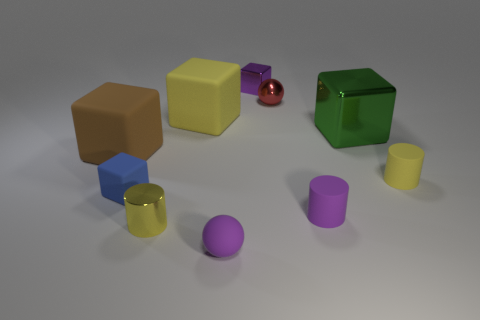There is a yellow block that is the same size as the brown matte thing; what material is it?
Give a very brief answer. Rubber. What shape is the red thing that is the same size as the blue object?
Provide a succinct answer. Sphere. What is the shape of the rubber thing that is on the left side of the small purple sphere and right of the blue rubber object?
Your response must be concise. Cube. What size is the matte cylinder in front of the small blue rubber thing?
Your answer should be compact. Small. Does the red thing have the same shape as the yellow shiny thing?
Provide a succinct answer. No. How many big objects are yellow matte things or yellow metal spheres?
Your response must be concise. 1. There is a brown rubber object; are there any cylinders on the left side of it?
Your answer should be compact. No. Are there an equal number of small purple blocks that are to the right of the green metallic thing and large purple metallic objects?
Your answer should be compact. Yes. There is a brown rubber object that is the same shape as the green metallic thing; what is its size?
Keep it short and to the point. Large. Does the small yellow metallic thing have the same shape as the large object that is on the right side of the small red metallic object?
Provide a succinct answer. No. 